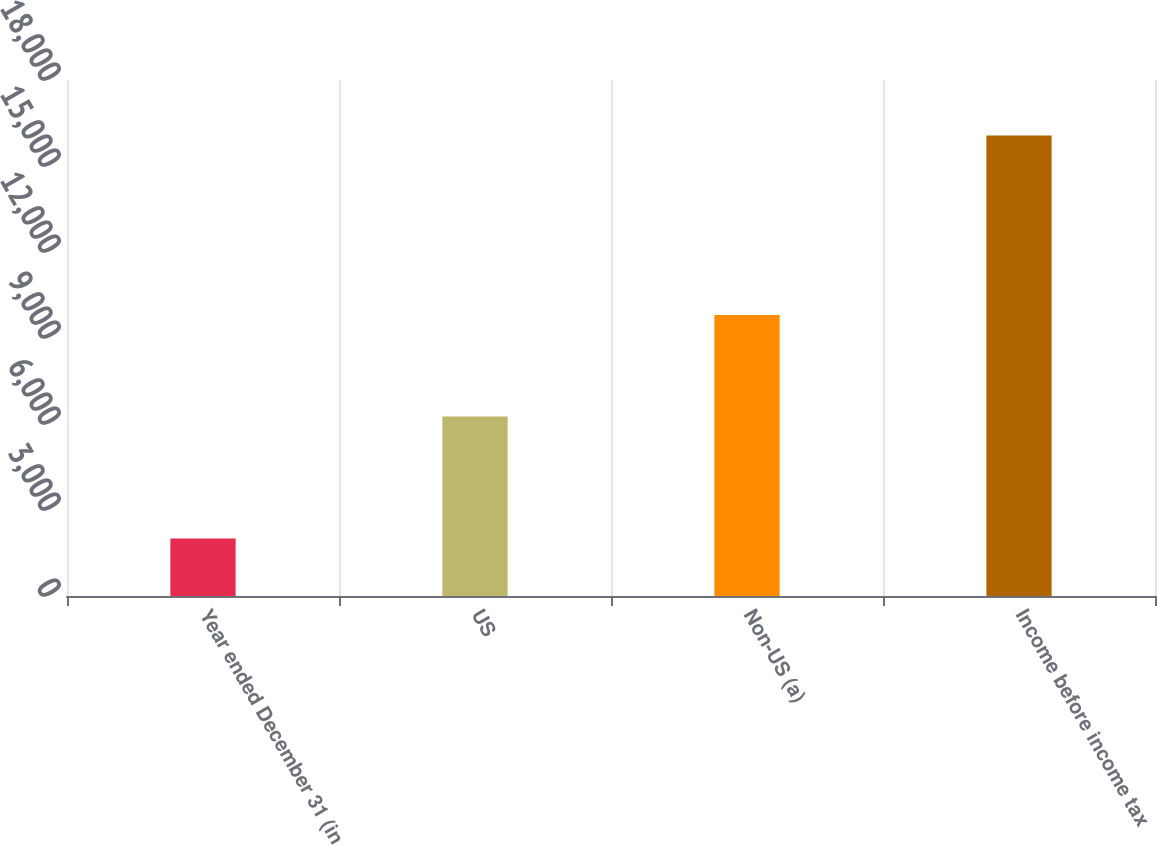Convert chart. <chart><loc_0><loc_0><loc_500><loc_500><bar_chart><fcel>Year ended December 31 (in<fcel>US<fcel>Non-US (a)<fcel>Income before income tax<nl><fcel>2009<fcel>6263<fcel>9804<fcel>16067<nl></chart> 